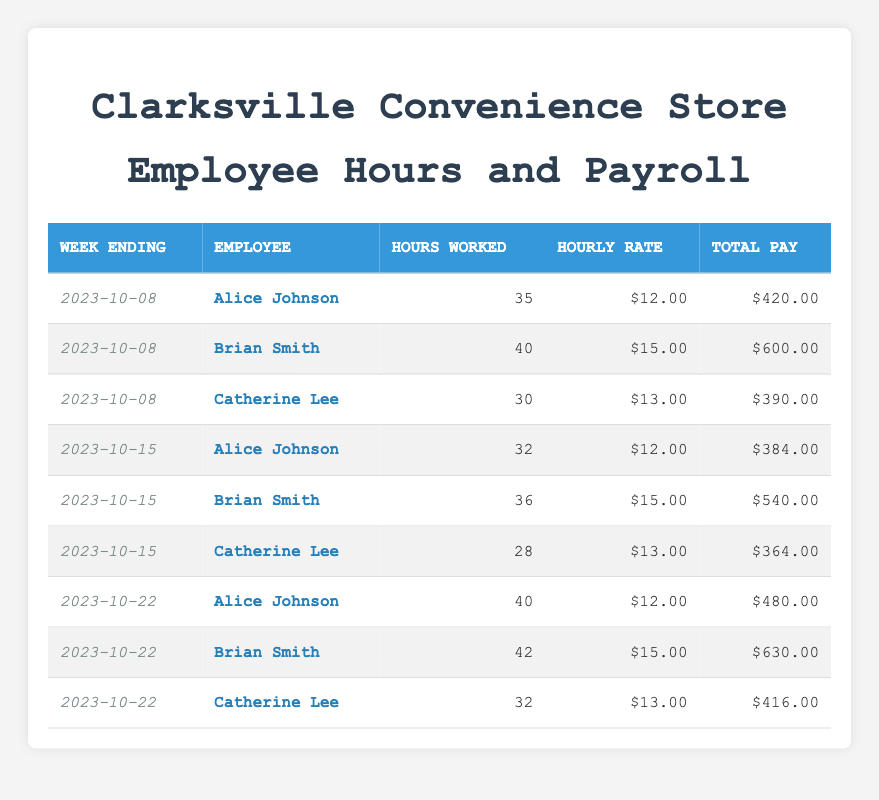What is the total payroll for the week ending October 8th? To find the total payroll, add the total pay of all employees for that week: $420 + $600 + $390 = $1410.
Answer: 1410 Who worked the most hours in the week ending October 15th? In that week, Alice Johnson worked 32 hours, Brian Smith worked 36 hours, and Catherine Lee worked 28 hours. Comparing the hours, Brian Smith has the highest at 36 hours.
Answer: Brian Smith What is the average hourly rate of all employees for the week ending October 22nd? For that week, the hourly rates were $12, $15, and $13. First, compute the average: (12 + 15 + 13) / 3 = 40 / 3 = 13.33.
Answer: 13.33 Did Alice Johnson work more than 35 hours in any week? Alice worked 35 hours in the week ending October 8th, 32 hours in the week ending October 15th, and 40 hours in the week ending October 22nd. She surpassed 35 hours only in the week ending October 22nd.
Answer: Yes What is the total pay for all employees in the week ending October 22nd? For the week ending October 22nd, the total pay is calculated as follows: Alice Johnson: $480 + Brian Smith: $630 + Catherine Lee: $416. The sum is $480 + $630 + $416 = $1526.
Answer: 1526 Is it true that Catherine Lee made more total pay than Alice Johnson in any of the weeks? Check each week: week ending Oct 8th: Catherine Lee: $390 < Alice Johnson: $420; Oct 15th: Catherine Lee: $364 < Alice Johnson: $384; Oct 22nd: Catherine Lee: $416 < Alice Johnson: $480. In all weeks, Catherine earned less than Alice.
Answer: No How many hours did Brian Smith work across all recorded weeks? Brian Smith worked 40 (Oct 8) + 36 (Oct 15) + 42 (Oct 22) = 118 hours in total across the three weeks.
Answer: 118 Which employee had the highest total pay for a single week? The highest total pay comes from Brian Smith for the week ending October 22nd with $630, more than any other employee's total pay in any week.
Answer: Brian Smith What is the difference in total pay between the highest and lowest earning week for Catherine Lee? Catherine Lee's highest total pay was $416 (Oct 22) and her lowest was $364 (Oct 15), giving a difference of $416 - $364 = $52.
Answer: 52 